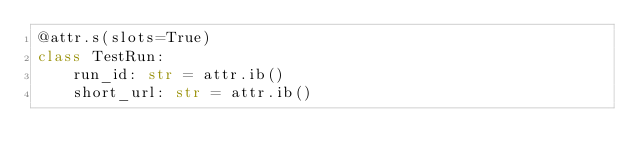Convert code to text. <code><loc_0><loc_0><loc_500><loc_500><_Python_>@attr.s(slots=True)
class TestRun:
    run_id: str = attr.ib()
    short_url: str = attr.ib()
</code> 